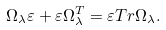Convert formula to latex. <formula><loc_0><loc_0><loc_500><loc_500>\Omega _ { \lambda } \varepsilon + \varepsilon \Omega _ { \lambda } ^ { T } = \varepsilon T r \Omega _ { \lambda } .</formula> 